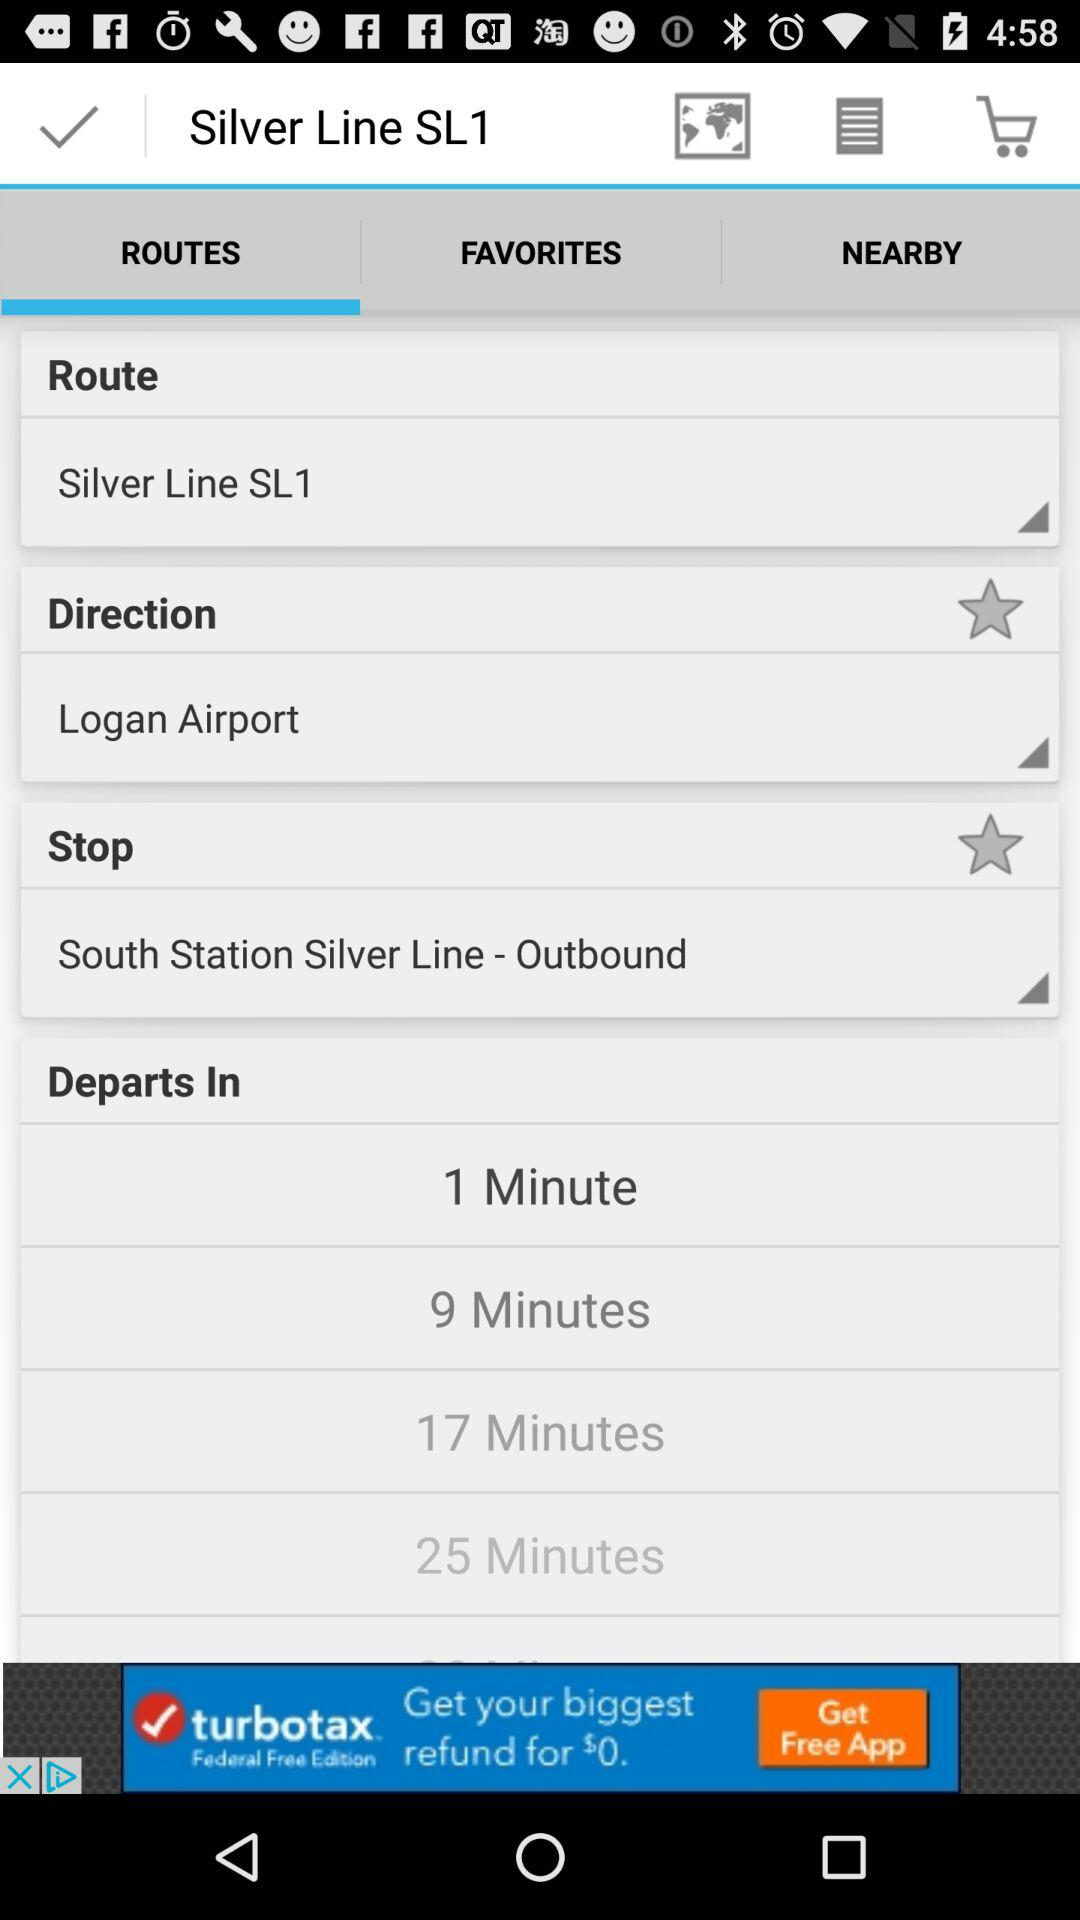Which tab is selected? The selected tab is "ROUTES". 